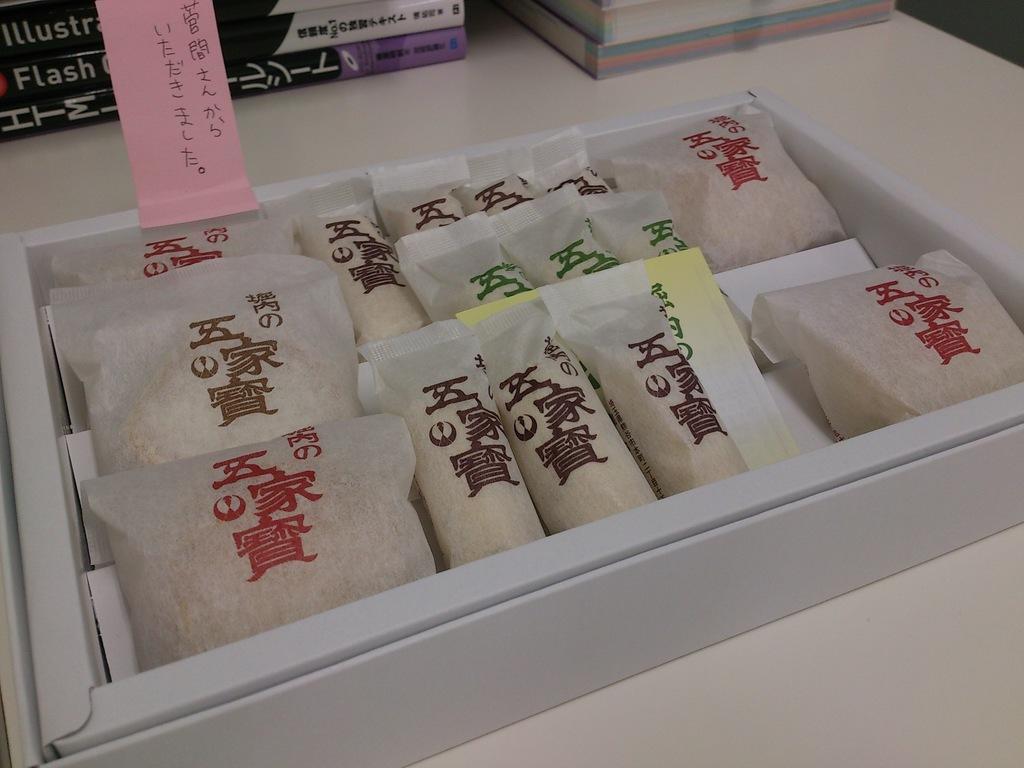Can you describe this image briefly? In this picture we can see a box with packets in it, books and these all are placed on the platform. 